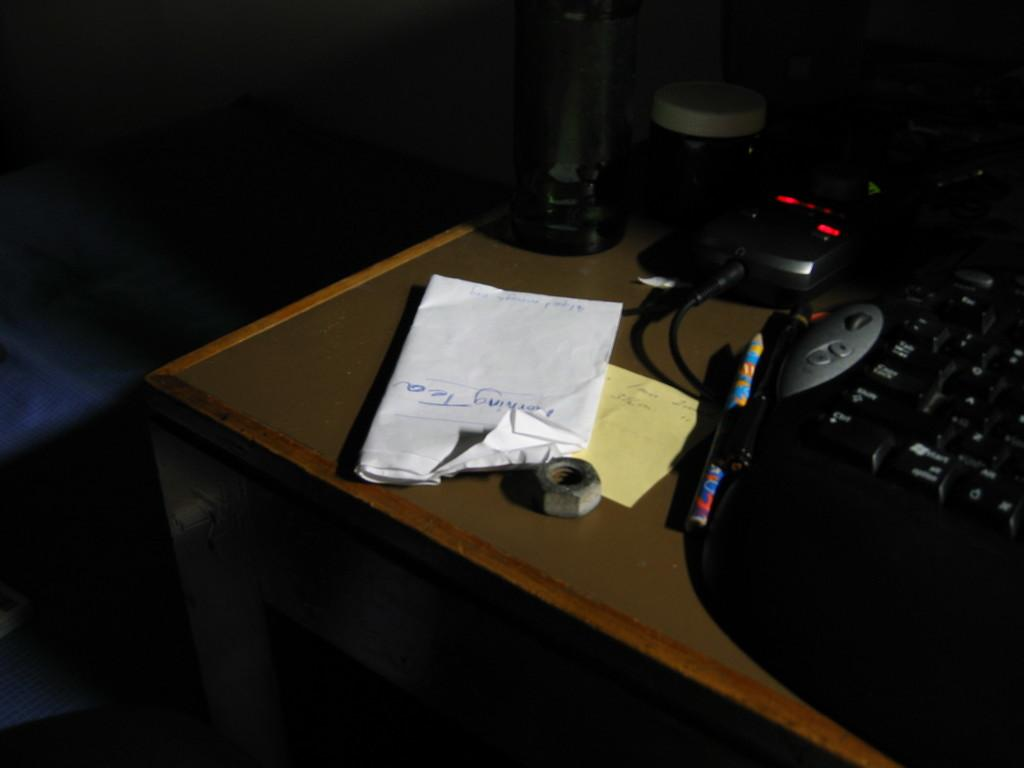<image>
Write a terse but informative summary of the picture. Bedside table with a paper note stating Morning Tea written on it. 